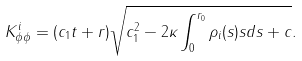<formula> <loc_0><loc_0><loc_500><loc_500>K ^ { i } _ { \phi \phi } = ( c _ { 1 } t + r ) \sqrt { c _ { 1 } ^ { 2 } - 2 \kappa \int _ { 0 } ^ { r _ { 0 } } { \rho _ { i } ( s ) s d s } + c } .</formula> 